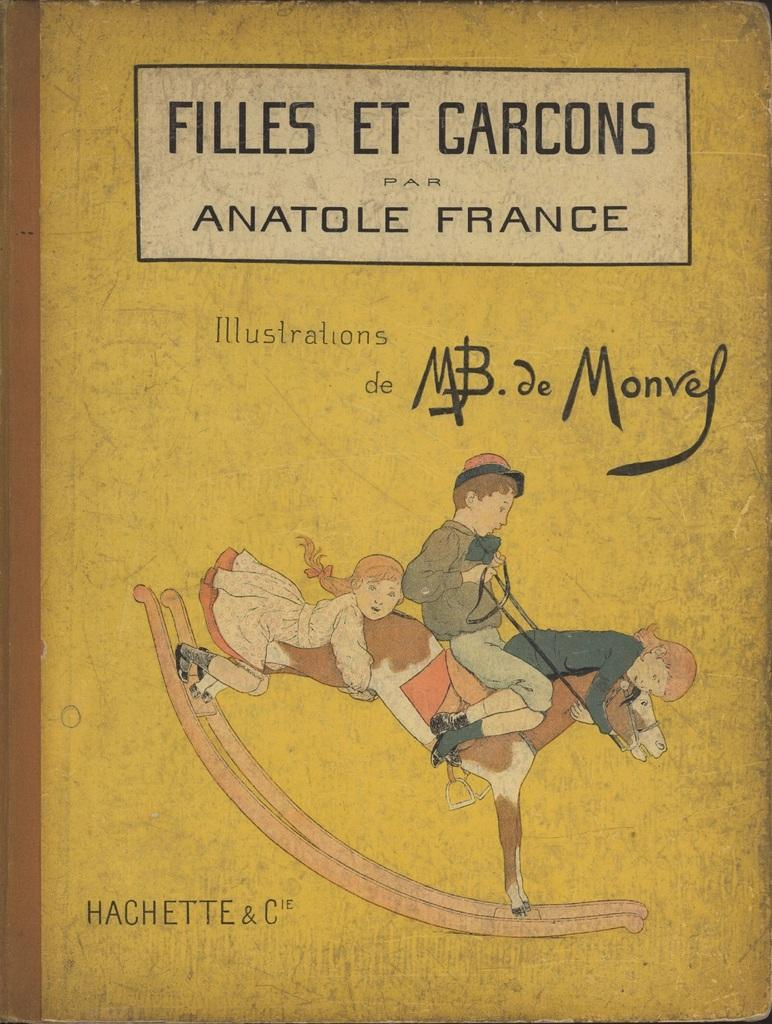<image>
Write a terse but informative summary of the picture. A book cover with three children on a hobby horse with the title Filles Et Garcons. 